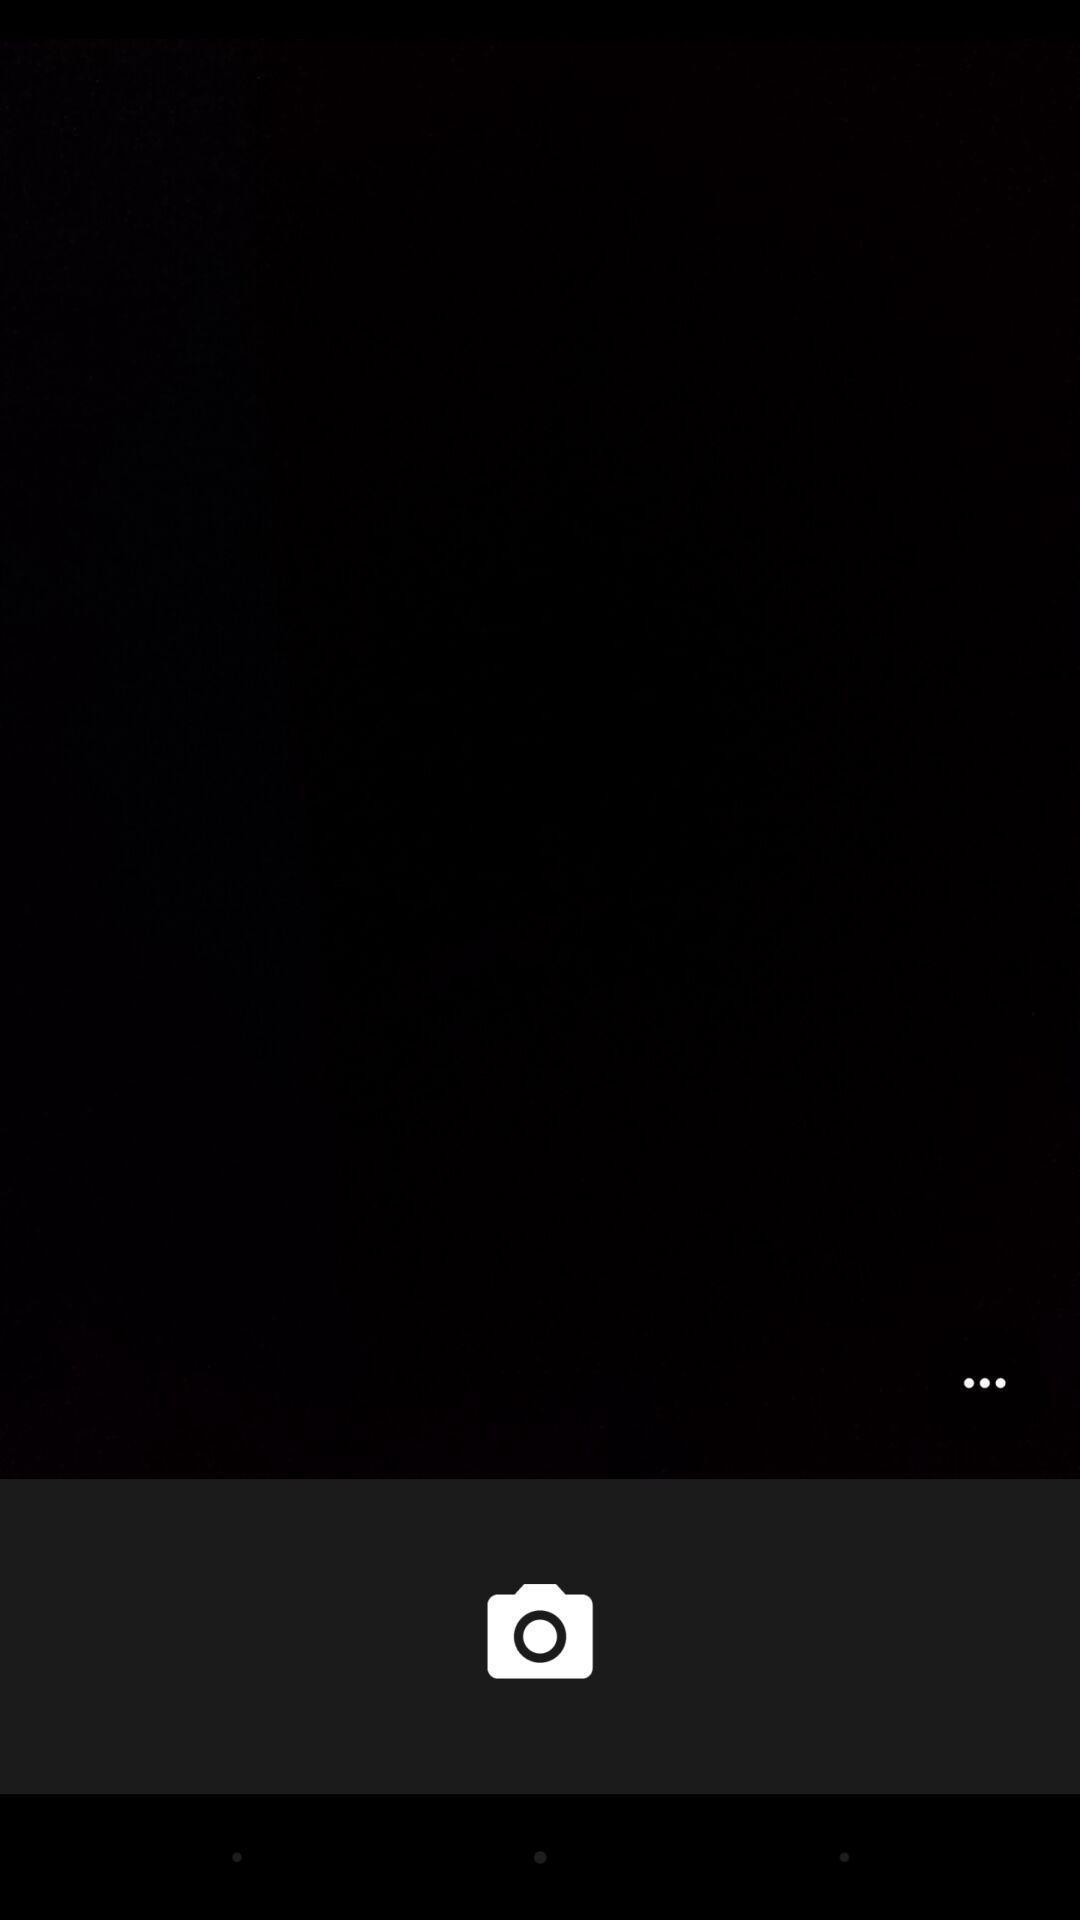Summarize the information in this screenshot. Page displaying a camera icon. 